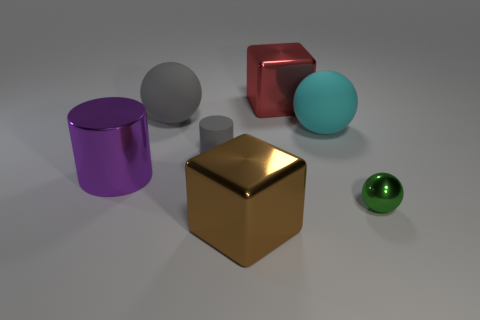Subtract all rubber spheres. How many spheres are left? 1 Add 1 matte cylinders. How many objects exist? 8 Subtract all cylinders. How many objects are left? 5 Subtract all small yellow matte cubes. Subtract all brown things. How many objects are left? 6 Add 5 big cyan objects. How many big cyan objects are left? 6 Add 7 yellow shiny cubes. How many yellow shiny cubes exist? 7 Subtract 0 brown cylinders. How many objects are left? 7 